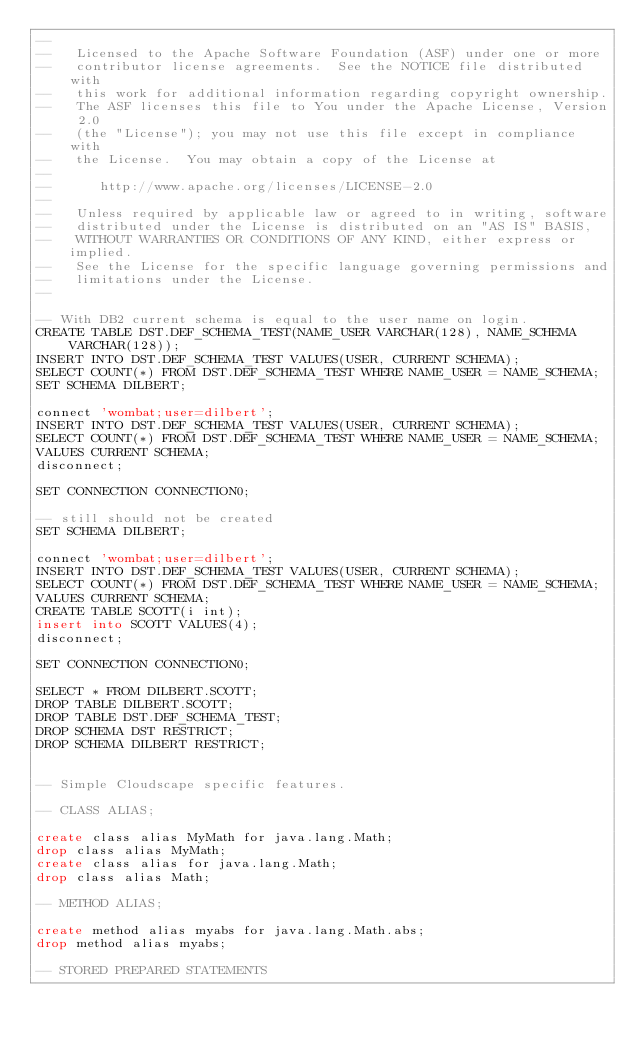<code> <loc_0><loc_0><loc_500><loc_500><_SQL_>--
--   Licensed to the Apache Software Foundation (ASF) under one or more
--   contributor license agreements.  See the NOTICE file distributed with
--   this work for additional information regarding copyright ownership.
--   The ASF licenses this file to You under the Apache License, Version 2.0
--   (the "License"); you may not use this file except in compliance with
--   the License.  You may obtain a copy of the License at
--
--      http://www.apache.org/licenses/LICENSE-2.0
--
--   Unless required by applicable law or agreed to in writing, software
--   distributed under the License is distributed on an "AS IS" BASIS,
--   WITHOUT WARRANTIES OR CONDITIONS OF ANY KIND, either express or implied.
--   See the License for the specific language governing permissions and
--   limitations under the License.
--

-- With DB2 current schema is equal to the user name on login.
CREATE TABLE DST.DEF_SCHEMA_TEST(NAME_USER VARCHAR(128), NAME_SCHEMA VARCHAR(128));
INSERT INTO DST.DEF_SCHEMA_TEST VALUES(USER, CURRENT SCHEMA);
SELECT COUNT(*) FROM DST.DEF_SCHEMA_TEST WHERE NAME_USER = NAME_SCHEMA;
SET SCHEMA DILBERT;

connect 'wombat;user=dilbert';
INSERT INTO DST.DEF_SCHEMA_TEST VALUES(USER, CURRENT SCHEMA);
SELECT COUNT(*) FROM DST.DEF_SCHEMA_TEST WHERE NAME_USER = NAME_SCHEMA;
VALUES CURRENT SCHEMA;
disconnect;

SET CONNECTION CONNECTION0;

-- still should not be created
SET SCHEMA DILBERT;

connect 'wombat;user=dilbert';
INSERT INTO DST.DEF_SCHEMA_TEST VALUES(USER, CURRENT SCHEMA);
SELECT COUNT(*) FROM DST.DEF_SCHEMA_TEST WHERE NAME_USER = NAME_SCHEMA;
VALUES CURRENT SCHEMA;
CREATE TABLE SCOTT(i int);
insert into SCOTT VALUES(4);
disconnect;

SET CONNECTION CONNECTION0;

SELECT * FROM DILBERT.SCOTT;
DROP TABLE DILBERT.SCOTT;
DROP TABLE DST.DEF_SCHEMA_TEST;
DROP SCHEMA DST RESTRICT;
DROP SCHEMA DILBERT RESTRICT;


-- Simple Cloudscape specific features.

-- CLASS ALIAS;

create class alias MyMath for java.lang.Math;
drop class alias MyMath;
create class alias for java.lang.Math;
drop class alias Math;

-- METHOD ALIAS;

create method alias myabs for java.lang.Math.abs;
drop method alias myabs;

-- STORED PREPARED STATEMENTS </code> 